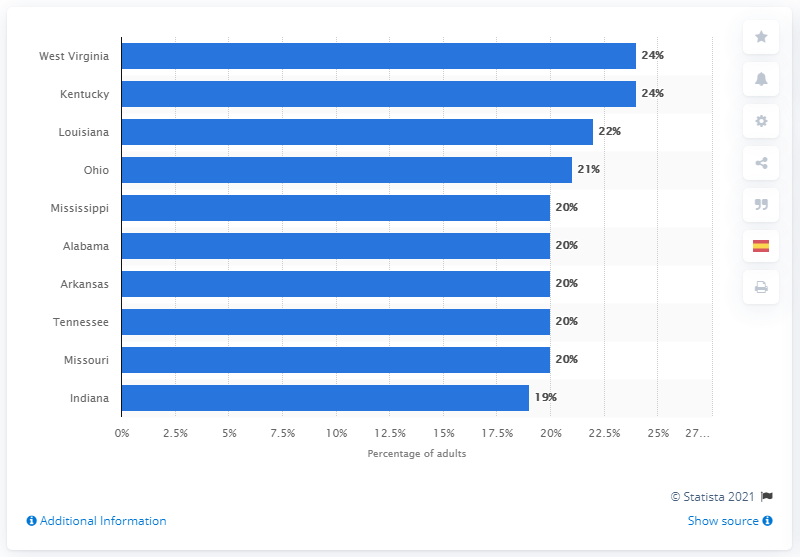Give some essential details in this illustration. In 2019, a study was conducted to determine the five states with the highest smoking rates among adults. The states found to have the highest rates were Mississippi, Alabama, Arkansas, Tennessee, and Missouri. The smoking rate in 2019 was an average of 21%. 